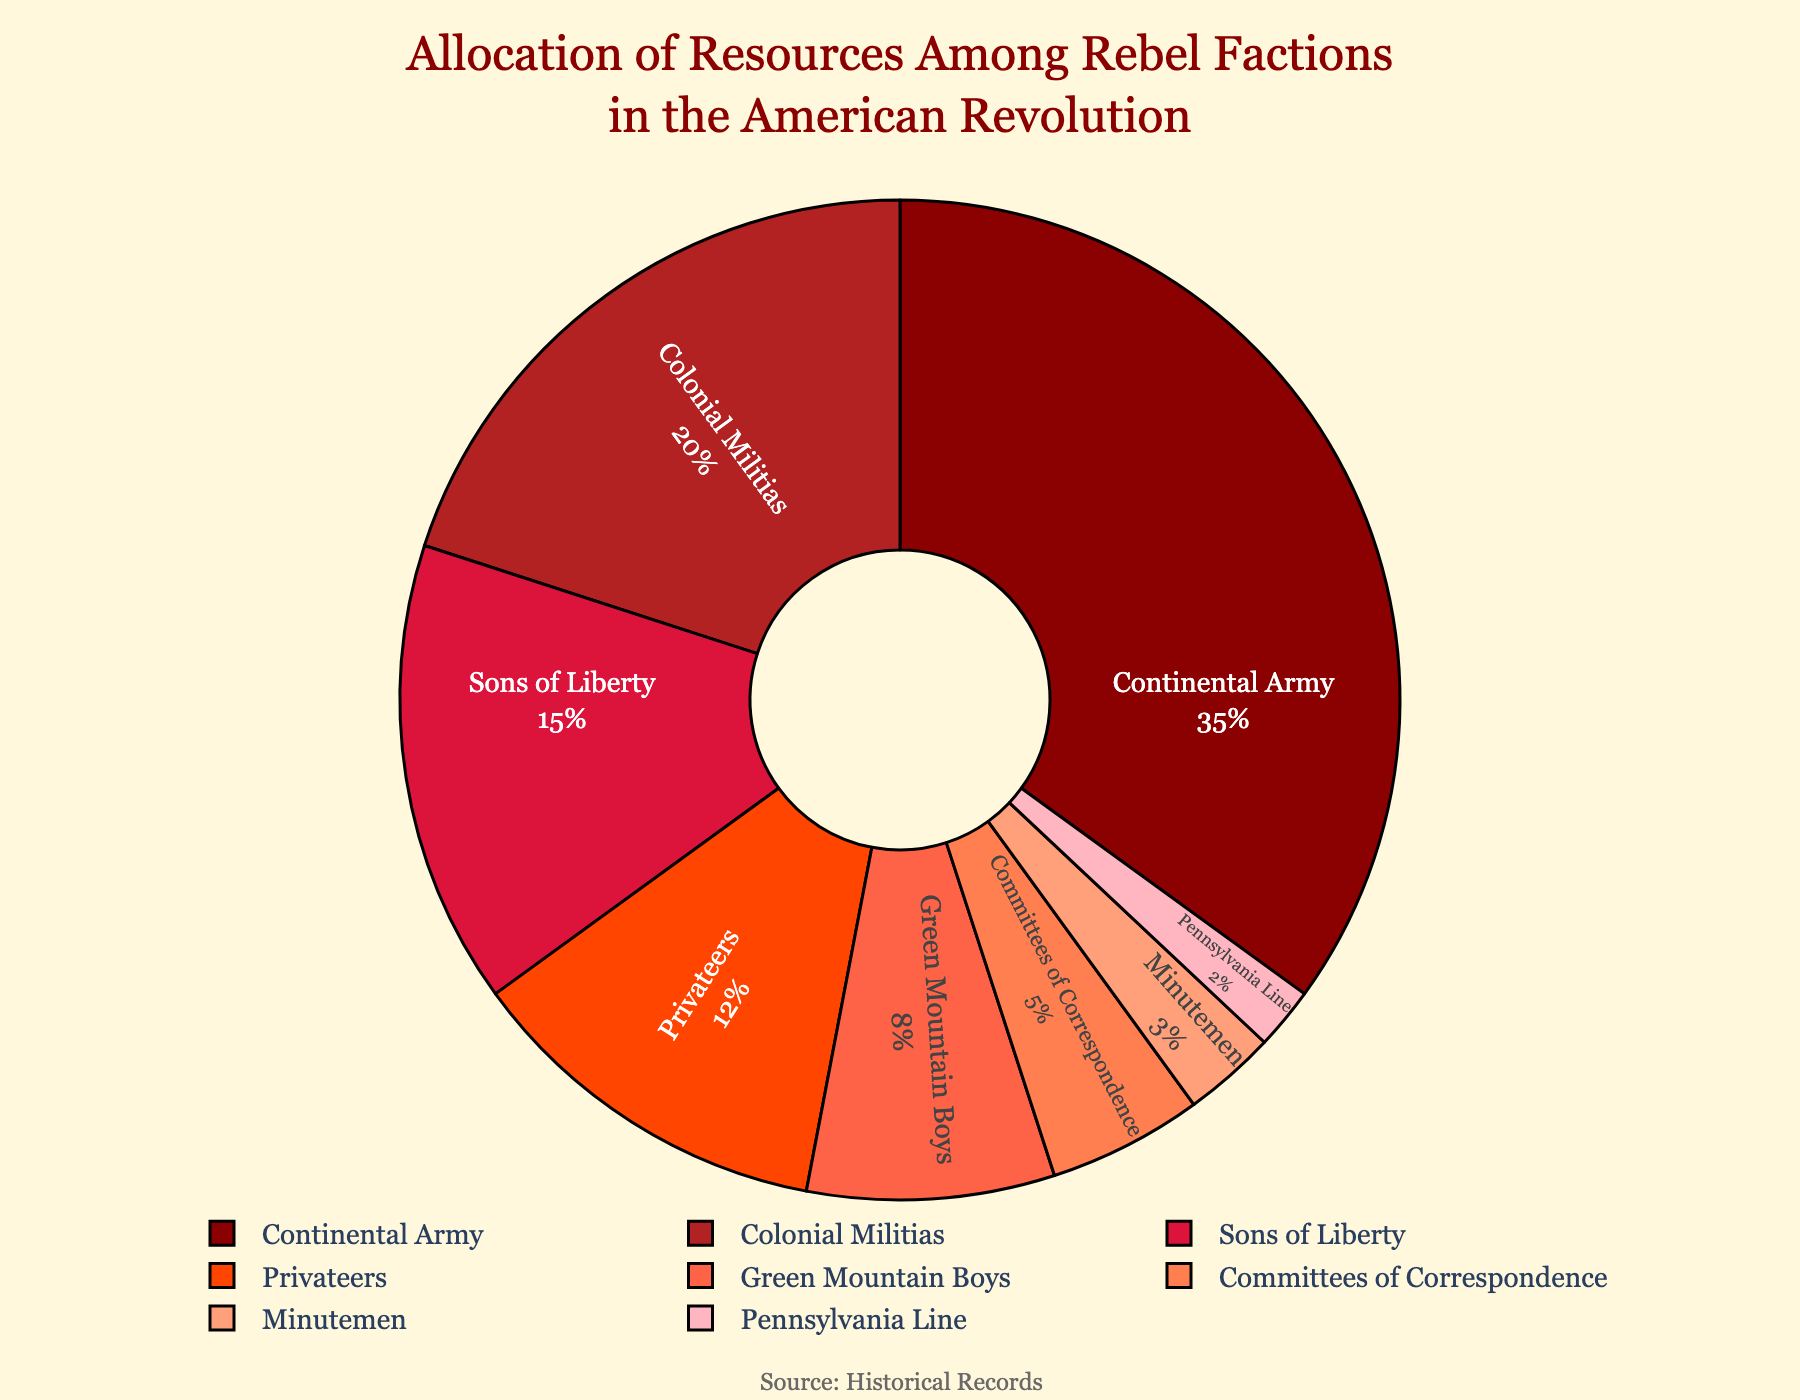What percentage of resources was allocated to the Continental Army and the Colonial Militias combined? Add the percentages of the Continental Army (35%) and the Colonial Militias (20%) together: 35 + 20 = 55%
Answer: 55% Which faction received more resources, Sons of Liberty or Privateers? Compare the percentages for Sons of Liberty (15%) and Privateers (12%): 15% is greater than 12%
Answer: Sons of Liberty What fraction of the total resources was given to the Minutemen compared to the Committees of Correspondence? Calculate the ratio of the Minutemen's resources (3%) to the Committees of Correspondence's resources (5%): 3/5 = 0.6
Answer: 0.6 Which faction received the smallest allocation of resources? Identify the faction with the lowest percentage: Pennsylvania Line at 2%
Answer: Pennsylvania Line How much more resources did the Green Mountain Boys receive compared to the Pennsylvania Line? Subtract the percentage of the Pennsylvania Line (2%) from the Green Mountain Boys (8%): 8 - 2 = 6%
Answer: 6% Is the sum of resources allocated to the Privateers and the Committees of Correspondence greater than that allocated to the Colonial Militias? Add the percentages of Privateers (12%) and Committees of Correspondence (5%) together and compare it to the Colonial Militias' percentage (20%): 12 + 5 = 17%, which is less than 20%
Answer: No Which three factions received the highest allocations of resources, in descending order? List the top three factions by their percentage: Continental Army (35%), Colonial Militias (20%), and Sons of Liberty (15%)
Answer: Continental Army, Colonial Militias, Sons of Liberty What is the difference in resource allocation between the faction with the highest allocation and the faction with the lowest? Subtract the percentage of the Pennsylvania Line (2%) from the Continental Army (35%): 35 - 2 = 33%
Answer: 33% What is the average percentage of resources allocated among the Sons of Liberty, Privateers, and Minutemen? Add the percentages of the Sons of Liberty (15%), Privateers (12%), and Minutemen (3%) and divide by 3: (15 + 12 + 3) / 3 = 10%
Answer: 10% 